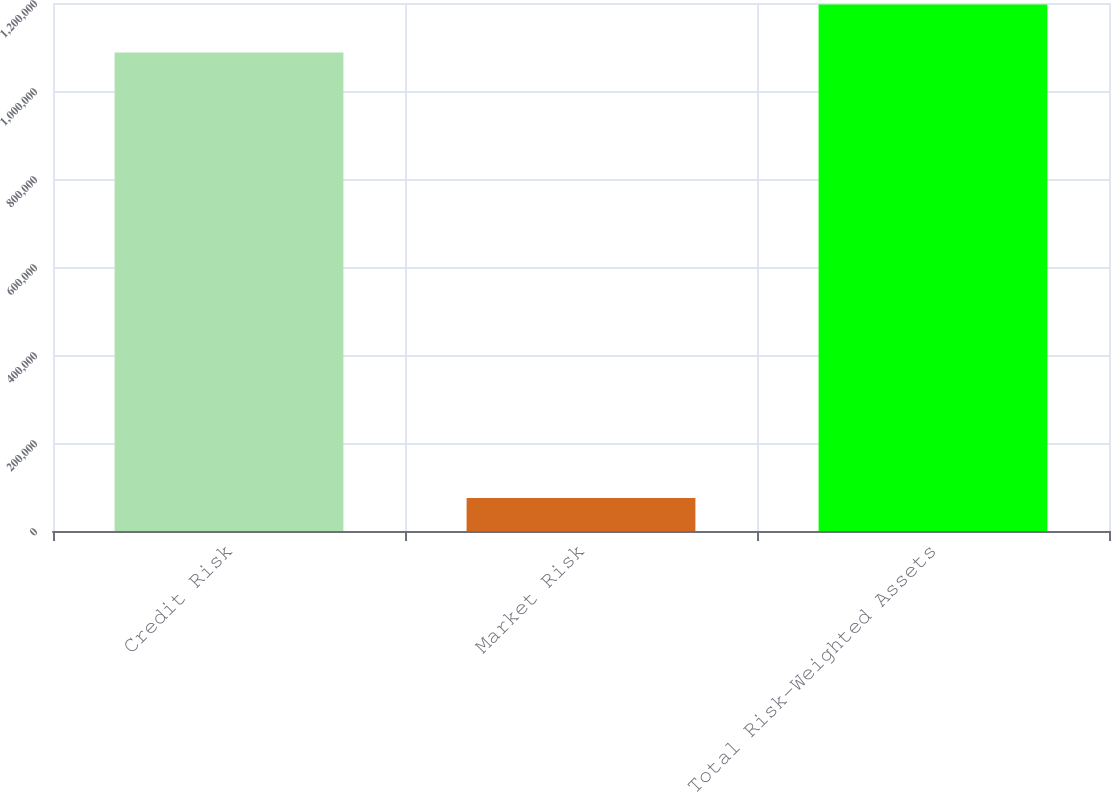Convert chart to OTSL. <chart><loc_0><loc_0><loc_500><loc_500><bar_chart><fcel>Credit Risk<fcel>Market Risk<fcel>Total Risk-Weighted Assets<nl><fcel>1.0877e+06<fcel>75185<fcel>1.19647e+06<nl></chart> 